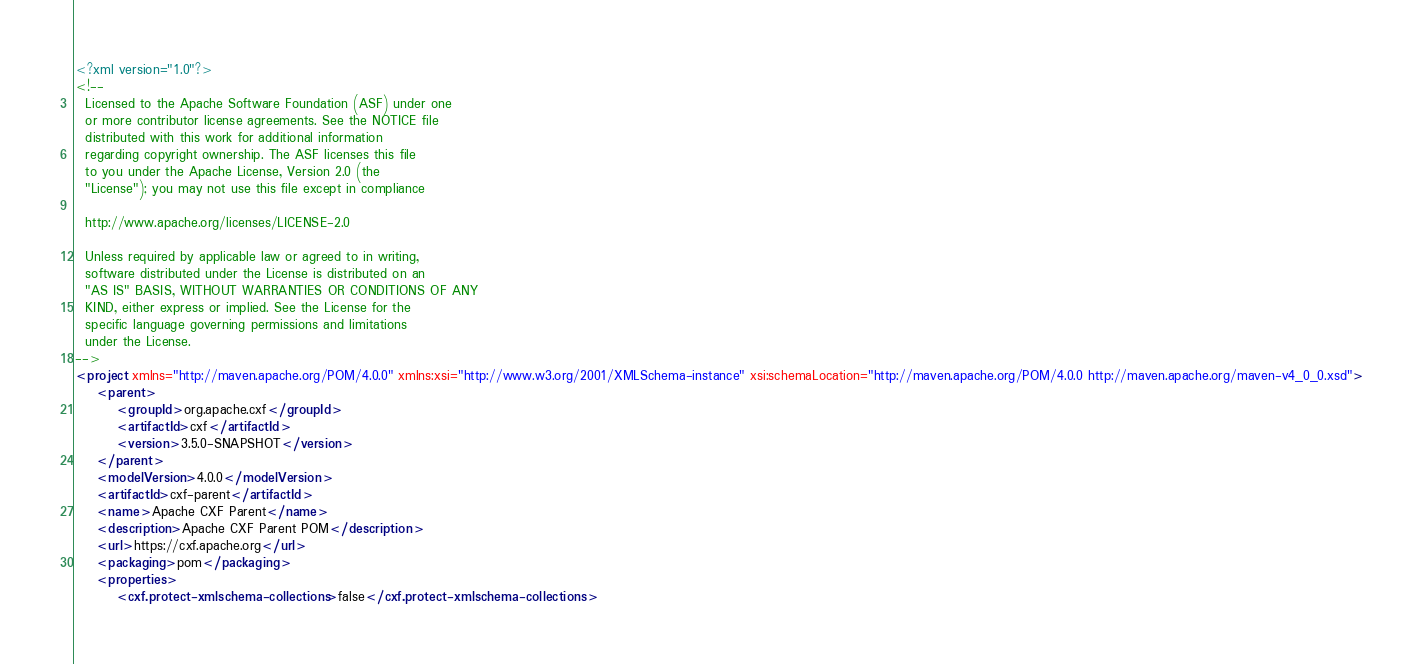<code> <loc_0><loc_0><loc_500><loc_500><_XML_><?xml version="1.0"?>
<!--
  Licensed to the Apache Software Foundation (ASF) under one
  or more contributor license agreements. See the NOTICE file
  distributed with this work for additional information
  regarding copyright ownership. The ASF licenses this file
  to you under the Apache License, Version 2.0 (the
  "License"); you may not use this file except in compliance

  http://www.apache.org/licenses/LICENSE-2.0

  Unless required by applicable law or agreed to in writing,
  software distributed under the License is distributed on an
  "AS IS" BASIS, WITHOUT WARRANTIES OR CONDITIONS OF ANY
  KIND, either express or implied. See the License for the
  specific language governing permissions and limitations
  under the License.
-->
<project xmlns="http://maven.apache.org/POM/4.0.0" xmlns:xsi="http://www.w3.org/2001/XMLSchema-instance" xsi:schemaLocation="http://maven.apache.org/POM/4.0.0 http://maven.apache.org/maven-v4_0_0.xsd">
    <parent>
        <groupId>org.apache.cxf</groupId>
        <artifactId>cxf</artifactId>
        <version>3.5.0-SNAPSHOT</version>
    </parent>
    <modelVersion>4.0.0</modelVersion>
    <artifactId>cxf-parent</artifactId>
    <name>Apache CXF Parent</name>
    <description>Apache CXF Parent POM</description>
    <url>https://cxf.apache.org</url>
    <packaging>pom</packaging>
    <properties>
        <cxf.protect-xmlschema-collections>false</cxf.protect-xmlschema-collections></code> 